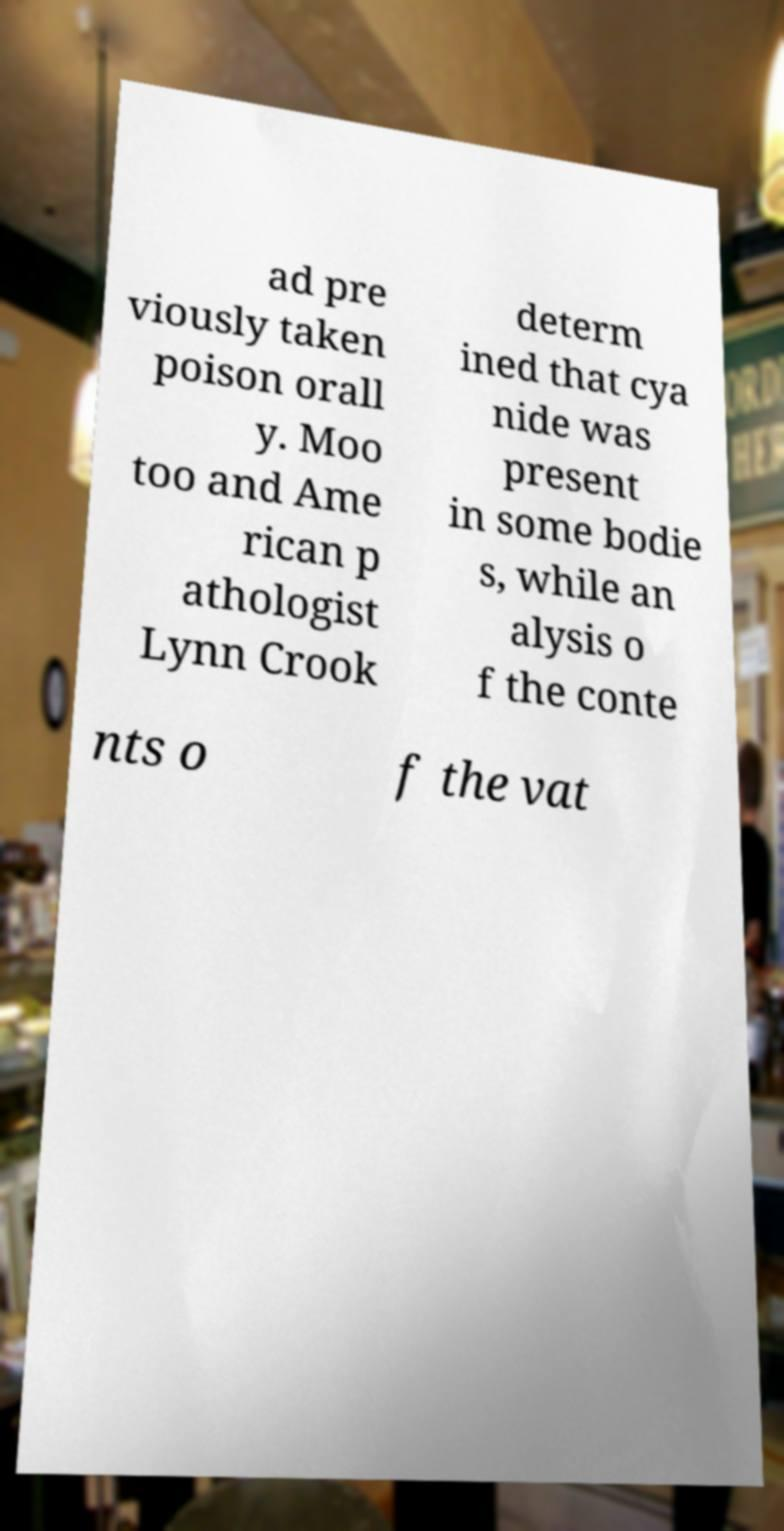What messages or text are displayed in this image? I need them in a readable, typed format. ad pre viously taken poison orall y. Moo too and Ame rican p athologist Lynn Crook determ ined that cya nide was present in some bodie s, while an alysis o f the conte nts o f the vat 